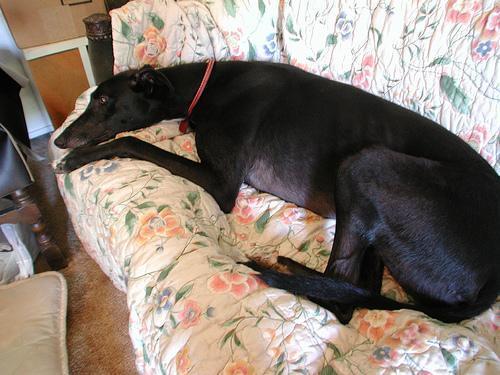How many dogs are there?
Give a very brief answer. 1. 